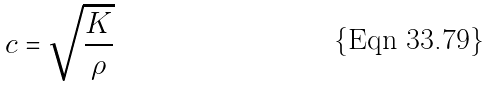Convert formula to latex. <formula><loc_0><loc_0><loc_500><loc_500>c = \sqrt { \frac { K } { \rho } }</formula> 